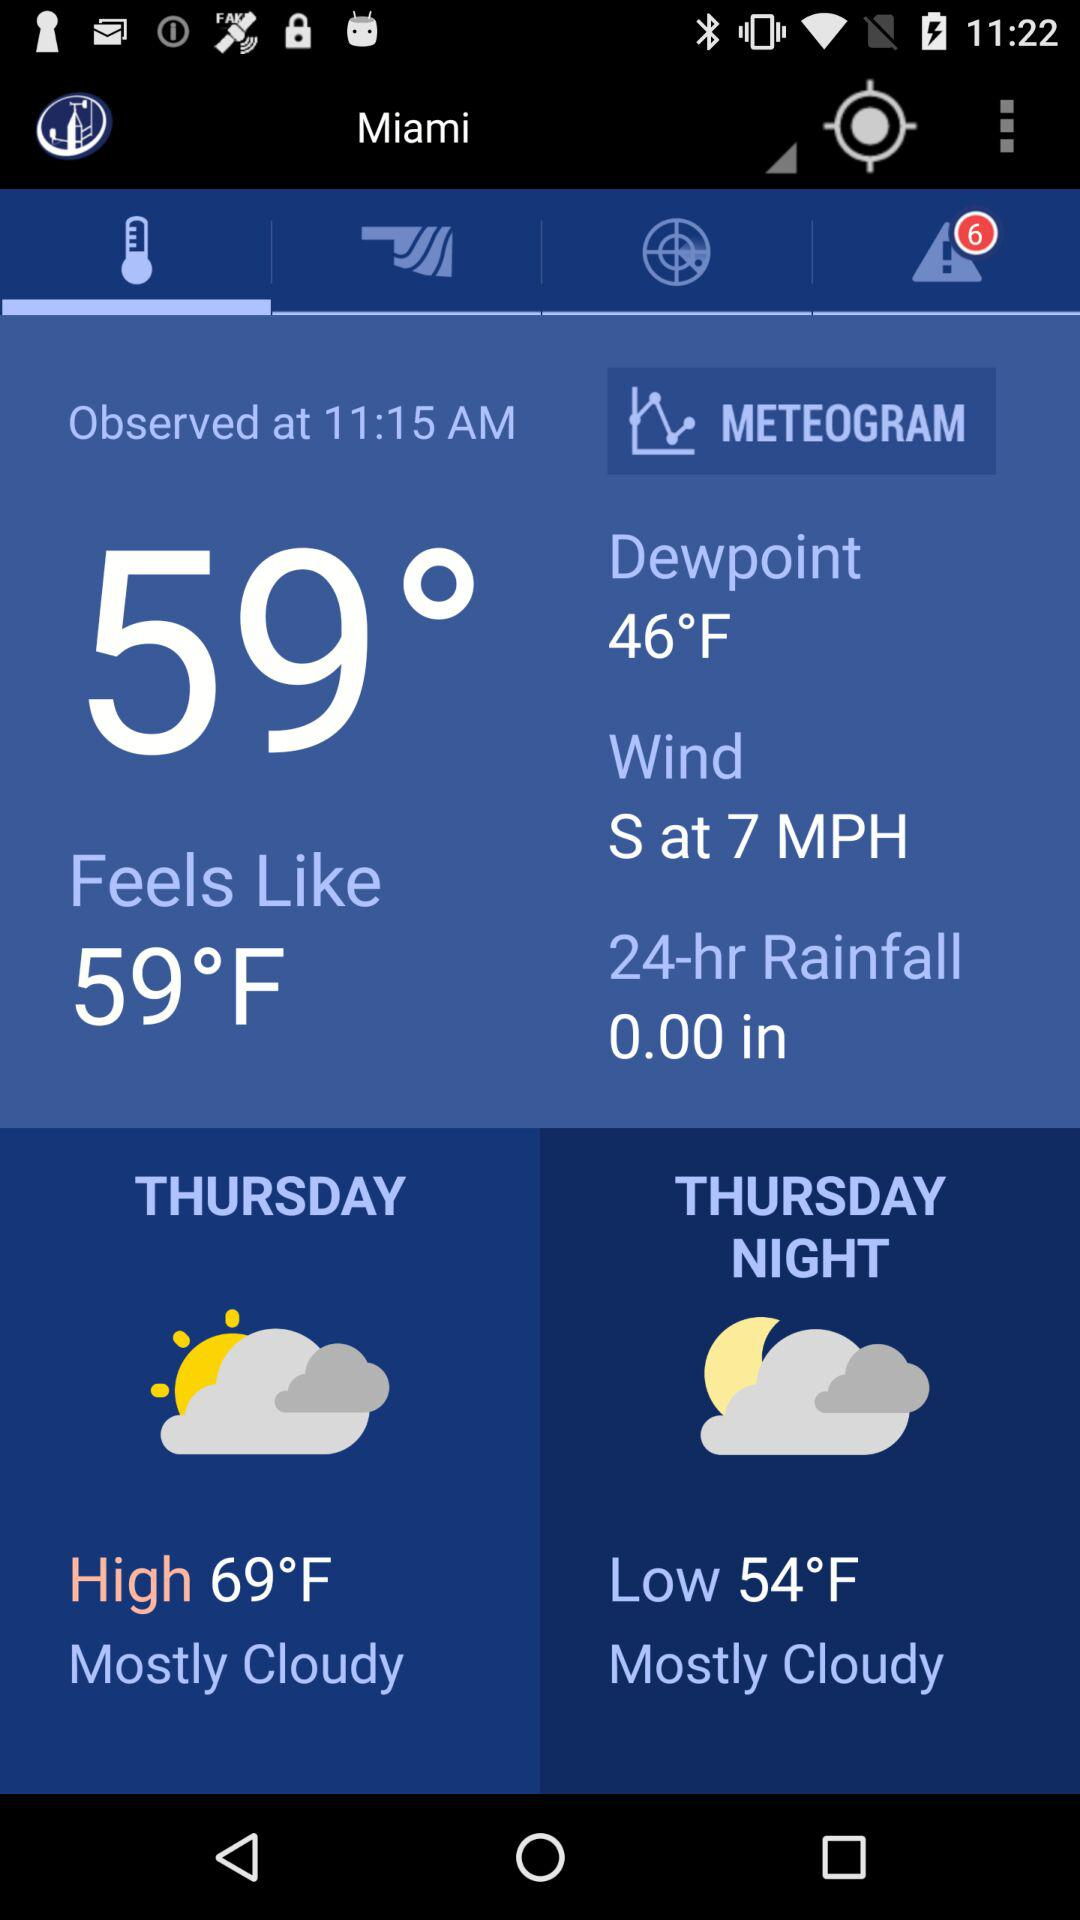How much is the dew point? The dew point is 46°F. 